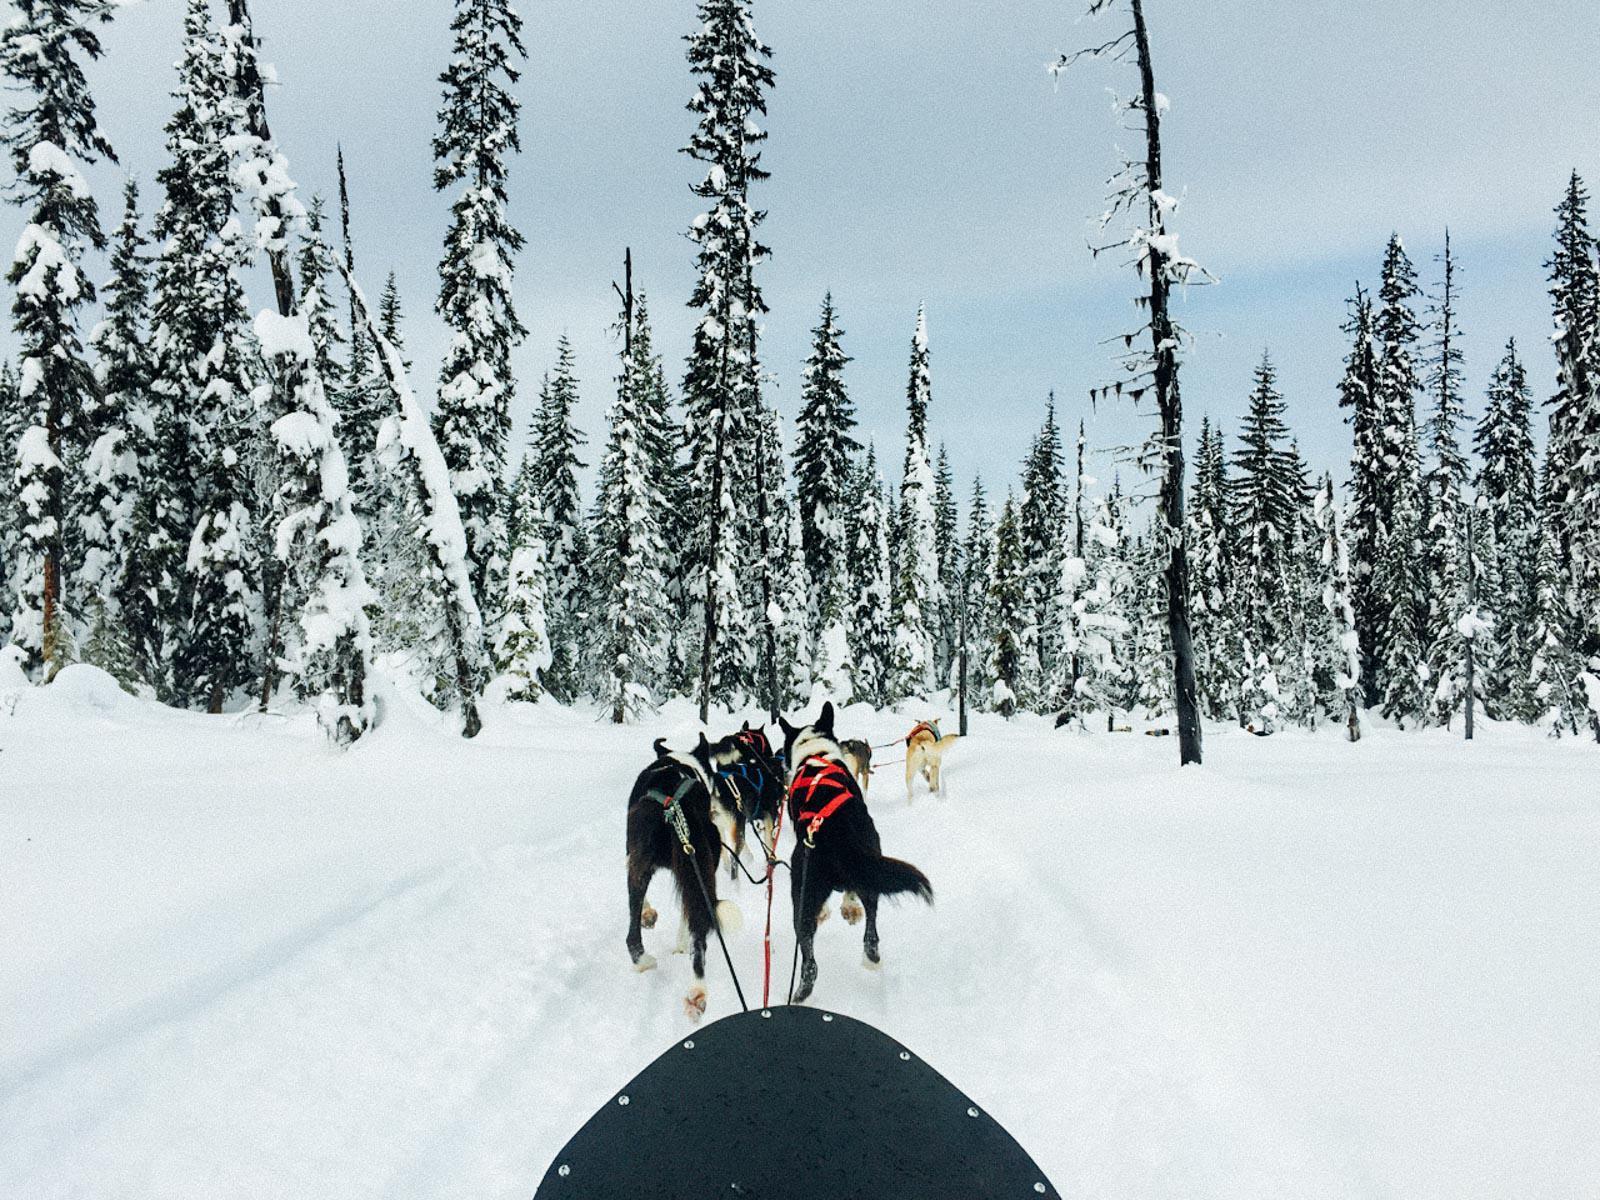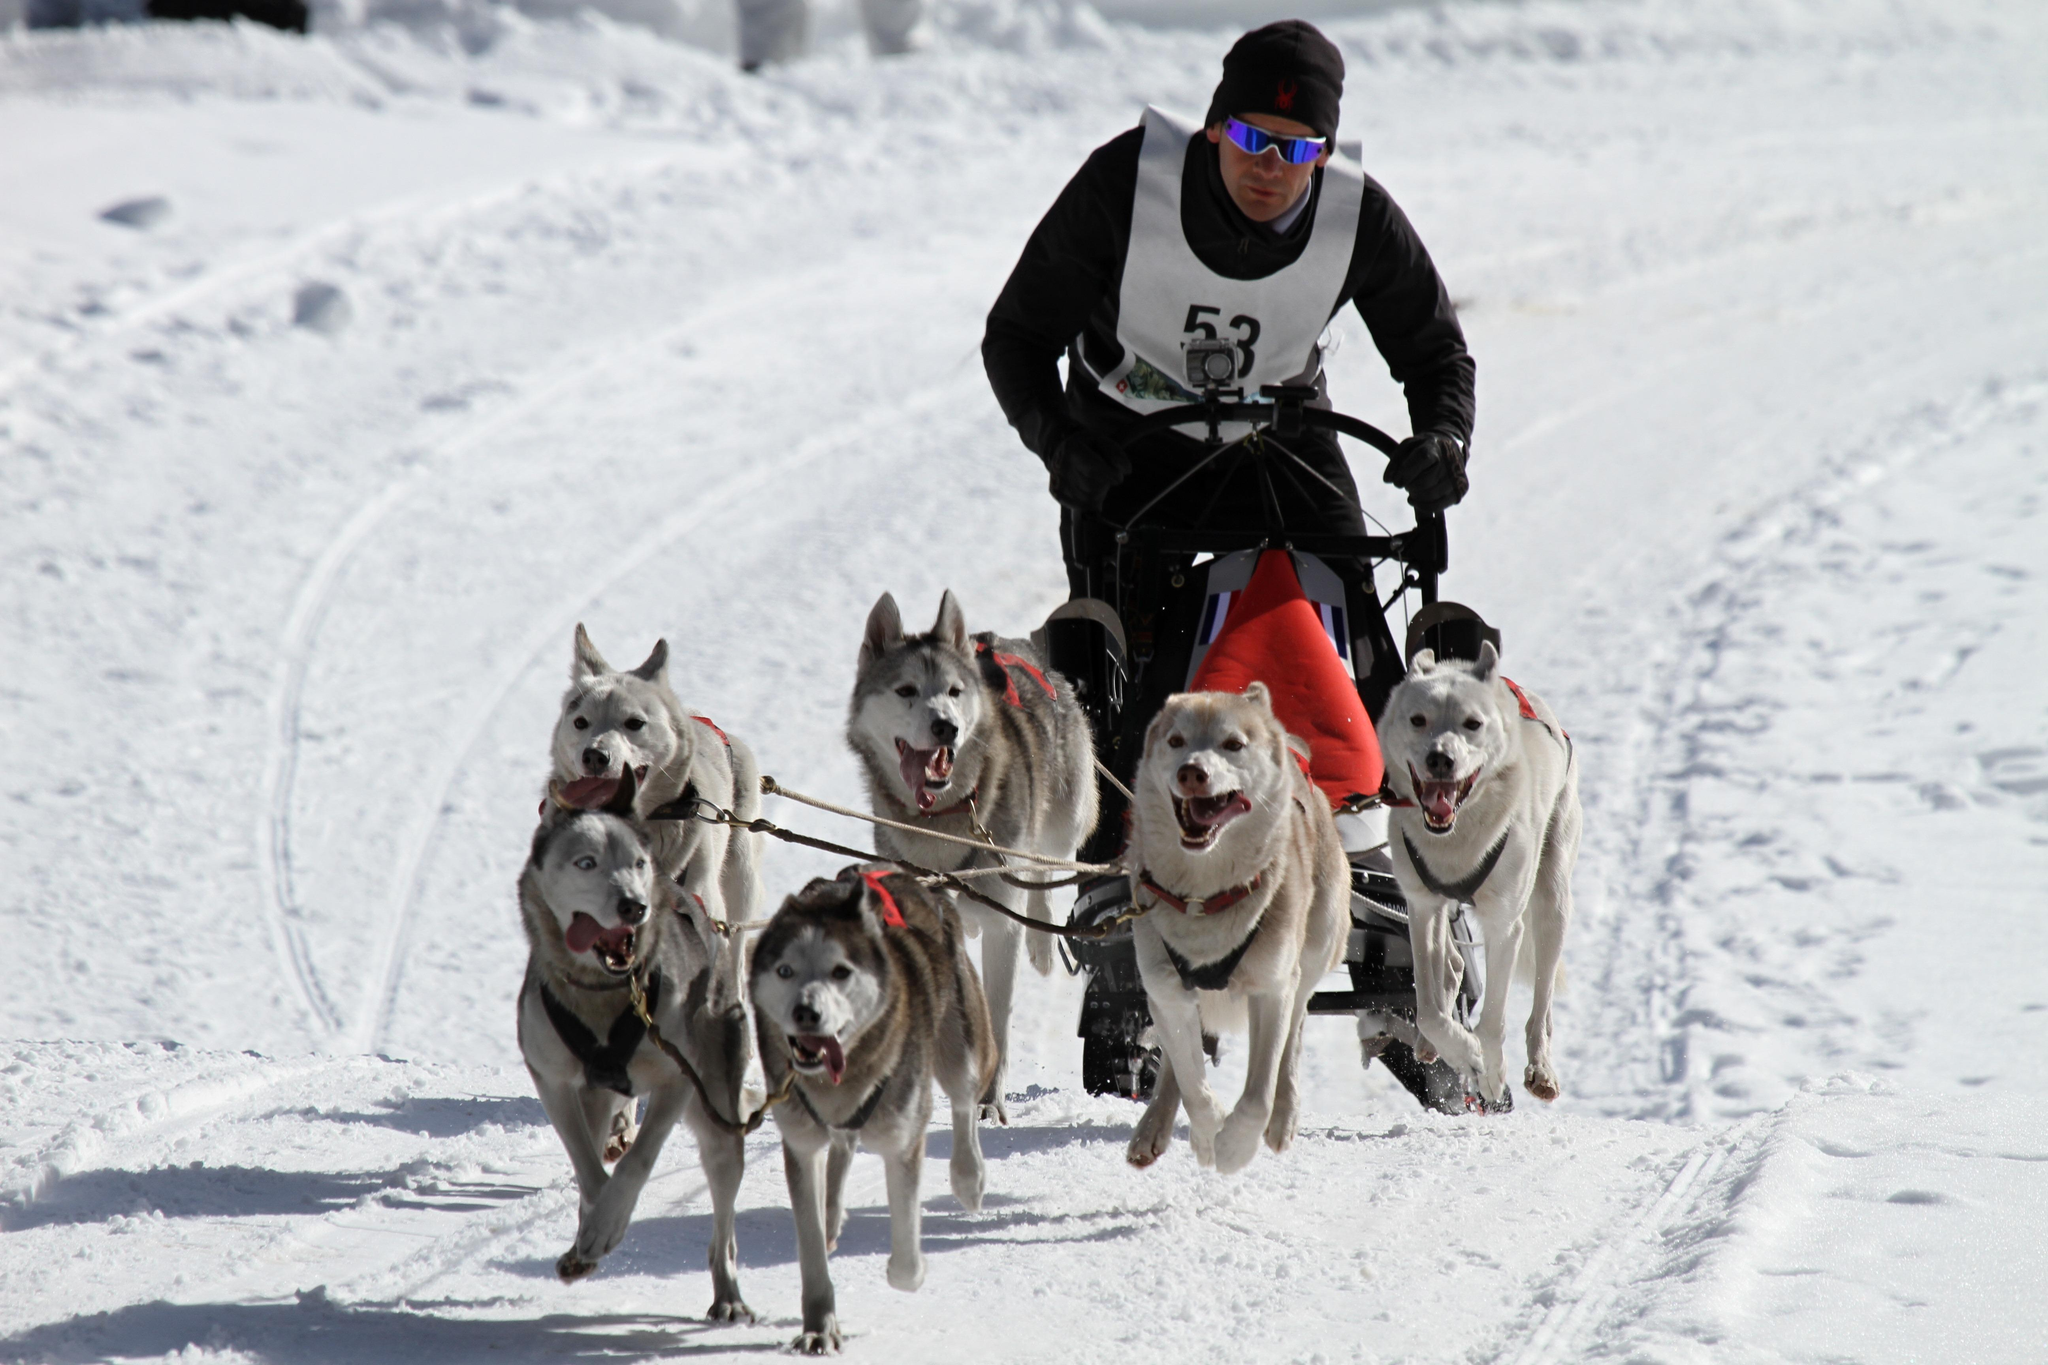The first image is the image on the left, the second image is the image on the right. Evaluate the accuracy of this statement regarding the images: "One image does not show a rider with a sled.". Is it true? Answer yes or no. Yes. The first image is the image on the left, the second image is the image on the right. Given the left and right images, does the statement "There is a person wearing red outerwear." hold true? Answer yes or no. No. 